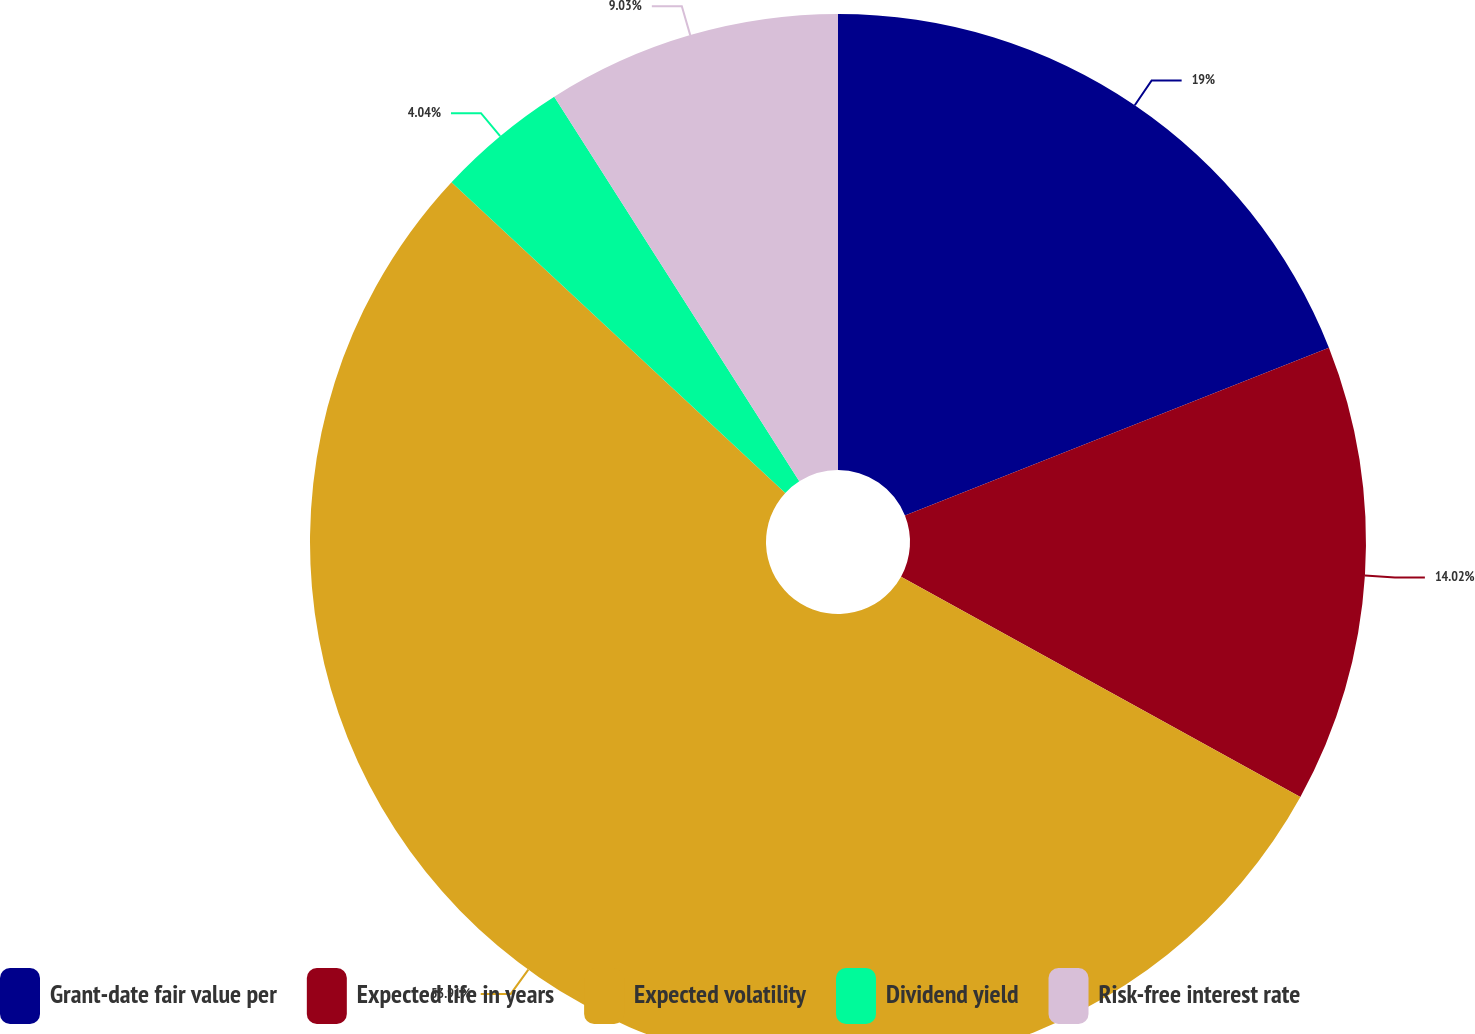Convert chart. <chart><loc_0><loc_0><loc_500><loc_500><pie_chart><fcel>Grant-date fair value per<fcel>Expected life in years<fcel>Expected volatility<fcel>Dividend yield<fcel>Risk-free interest rate<nl><fcel>19.0%<fcel>14.02%<fcel>53.91%<fcel>4.04%<fcel>9.03%<nl></chart> 